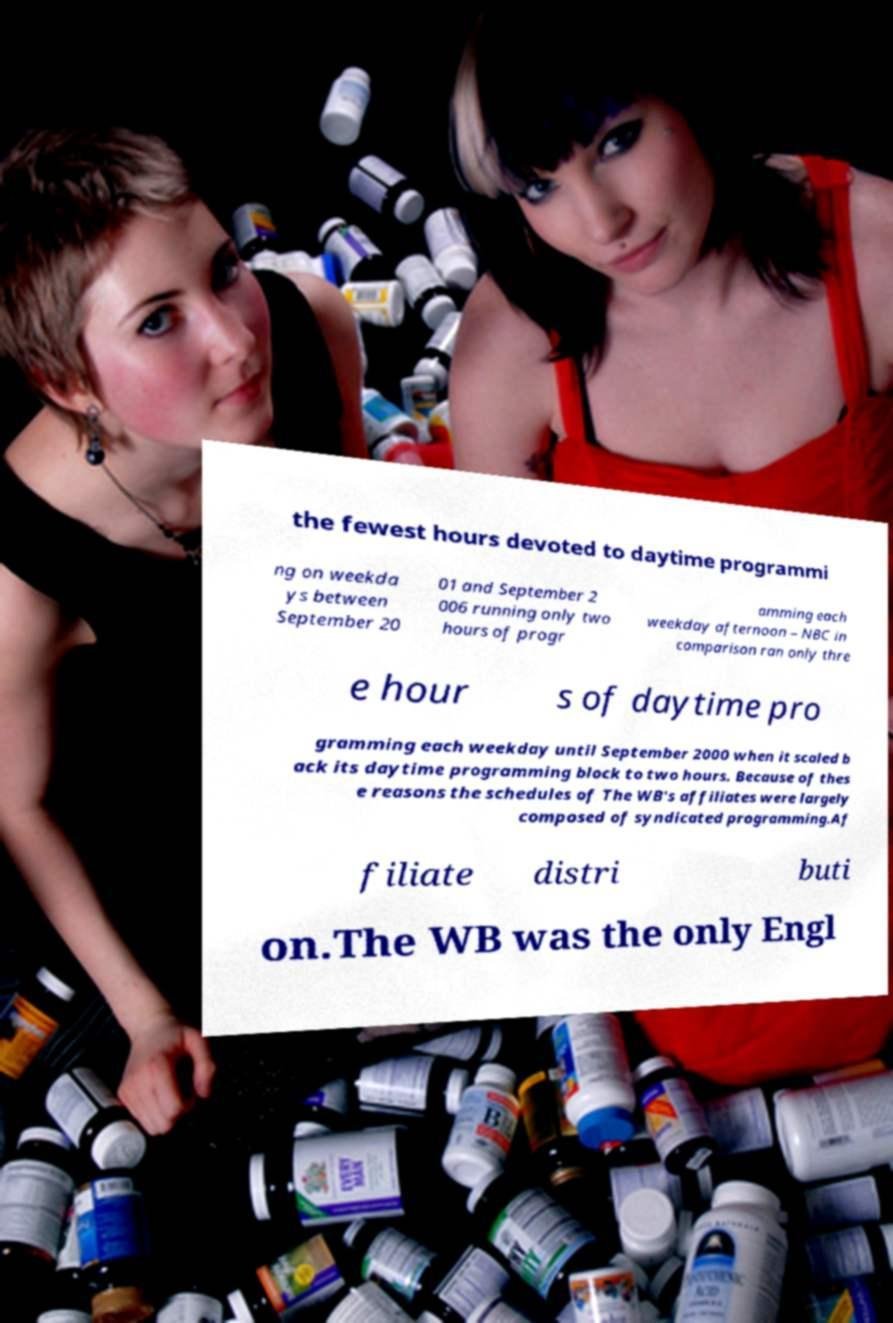For documentation purposes, I need the text within this image transcribed. Could you provide that? the fewest hours devoted to daytime programmi ng on weekda ys between September 20 01 and September 2 006 running only two hours of progr amming each weekday afternoon – NBC in comparison ran only thre e hour s of daytime pro gramming each weekday until September 2000 when it scaled b ack its daytime programming block to two hours. Because of thes e reasons the schedules of The WB's affiliates were largely composed of syndicated programming.Af filiate distri buti on.The WB was the only Engl 